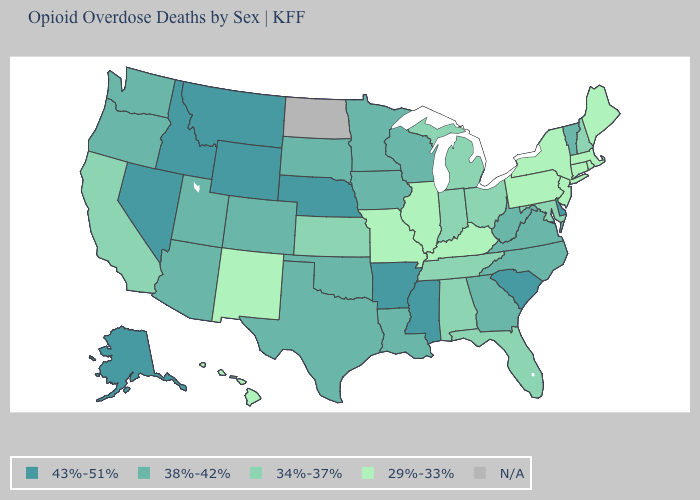Does the first symbol in the legend represent the smallest category?
Short answer required. No. Does Idaho have the highest value in the West?
Quick response, please. Yes. Is the legend a continuous bar?
Give a very brief answer. No. What is the lowest value in the West?
Concise answer only. 29%-33%. What is the value of California?
Answer briefly. 34%-37%. Is the legend a continuous bar?
Be succinct. No. Name the states that have a value in the range N/A?
Concise answer only. North Dakota. Does North Carolina have the highest value in the USA?
Give a very brief answer. No. What is the value of Louisiana?
Give a very brief answer. 38%-42%. Name the states that have a value in the range 38%-42%?
Short answer required. Arizona, Colorado, Georgia, Iowa, Louisiana, Minnesota, North Carolina, Oklahoma, Oregon, South Dakota, Texas, Utah, Vermont, Virginia, Washington, West Virginia, Wisconsin. Among the states that border Nevada , which have the highest value?
Write a very short answer. Idaho. Name the states that have a value in the range 29%-33%?
Concise answer only. Connecticut, Hawaii, Illinois, Kentucky, Maine, Massachusetts, Missouri, New Jersey, New Mexico, New York, Pennsylvania, Rhode Island. What is the value of Iowa?
Keep it brief. 38%-42%. 